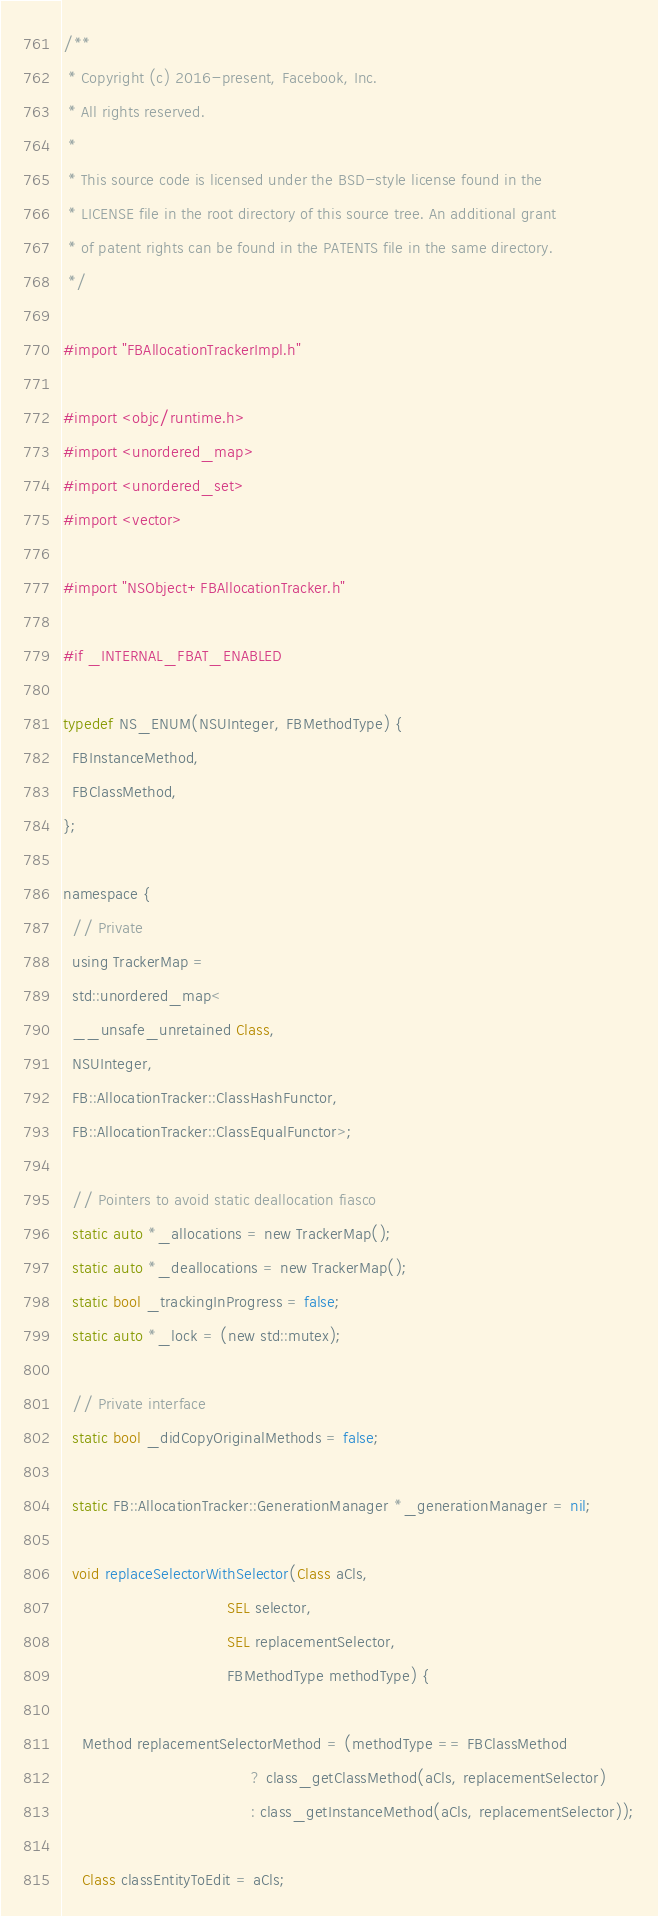Convert code to text. <code><loc_0><loc_0><loc_500><loc_500><_ObjectiveC_>/**
 * Copyright (c) 2016-present, Facebook, Inc.
 * All rights reserved.
 *
 * This source code is licensed under the BSD-style license found in the
 * LICENSE file in the root directory of this source tree. An additional grant
 * of patent rights can be found in the PATENTS file in the same directory.
 */

#import "FBAllocationTrackerImpl.h"

#import <objc/runtime.h>
#import <unordered_map>
#import <unordered_set>
#import <vector>

#import "NSObject+FBAllocationTracker.h"

#if _INTERNAL_FBAT_ENABLED

typedef NS_ENUM(NSUInteger, FBMethodType) {
  FBInstanceMethod,
  FBClassMethod,
};

namespace {
  // Private
  using TrackerMap =
  std::unordered_map<
  __unsafe_unretained Class,
  NSUInteger,
  FB::AllocationTracker::ClassHashFunctor,
  FB::AllocationTracker::ClassEqualFunctor>;

  // Pointers to avoid static deallocation fiasco
  static auto *_allocations = new TrackerMap();
  static auto *_deallocations = new TrackerMap();
  static bool _trackingInProgress = false;
  static auto *_lock = (new std::mutex);

  // Private interface
  static bool _didCopyOriginalMethods = false;

  static FB::AllocationTracker::GenerationManager *_generationManager = nil;

  void replaceSelectorWithSelector(Class aCls,
                                   SEL selector,
                                   SEL replacementSelector,
                                   FBMethodType methodType) {

    Method replacementSelectorMethod = (methodType == FBClassMethod
                                        ? class_getClassMethod(aCls, replacementSelector)
                                        : class_getInstanceMethod(aCls, replacementSelector));

    Class classEntityToEdit = aCls;</code> 